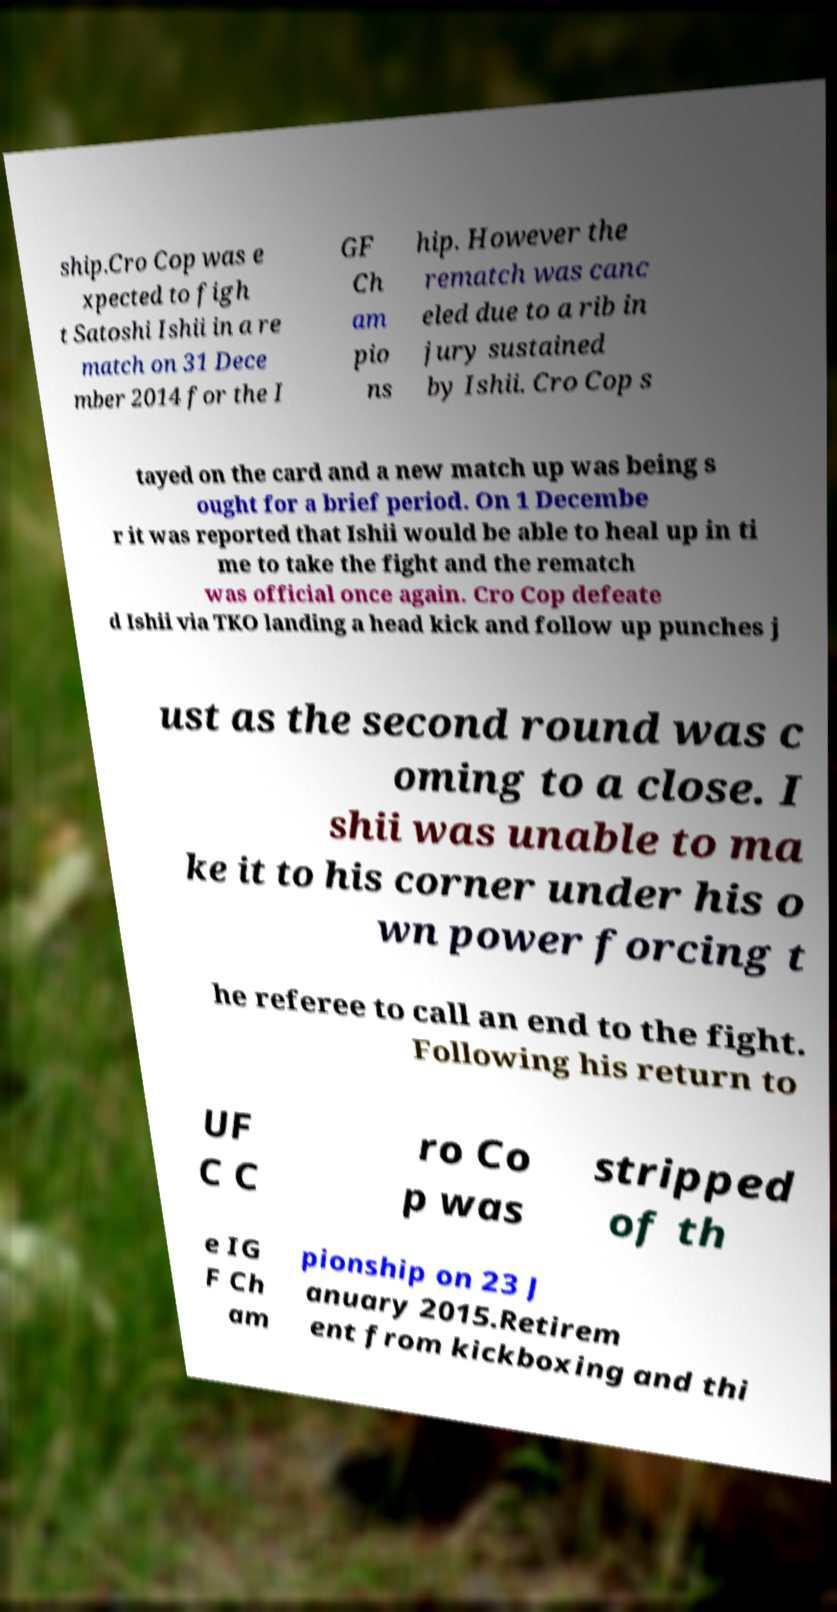I need the written content from this picture converted into text. Can you do that? ship.Cro Cop was e xpected to figh t Satoshi Ishii in a re match on 31 Dece mber 2014 for the I GF Ch am pio ns hip. However the rematch was canc eled due to a rib in jury sustained by Ishii. Cro Cop s tayed on the card and a new match up was being s ought for a brief period. On 1 Decembe r it was reported that Ishii would be able to heal up in ti me to take the fight and the rematch was official once again. Cro Cop defeate d Ishii via TKO landing a head kick and follow up punches j ust as the second round was c oming to a close. I shii was unable to ma ke it to his corner under his o wn power forcing t he referee to call an end to the fight. Following his return to UF C C ro Co p was stripped of th e IG F Ch am pionship on 23 J anuary 2015.Retirem ent from kickboxing and thi 